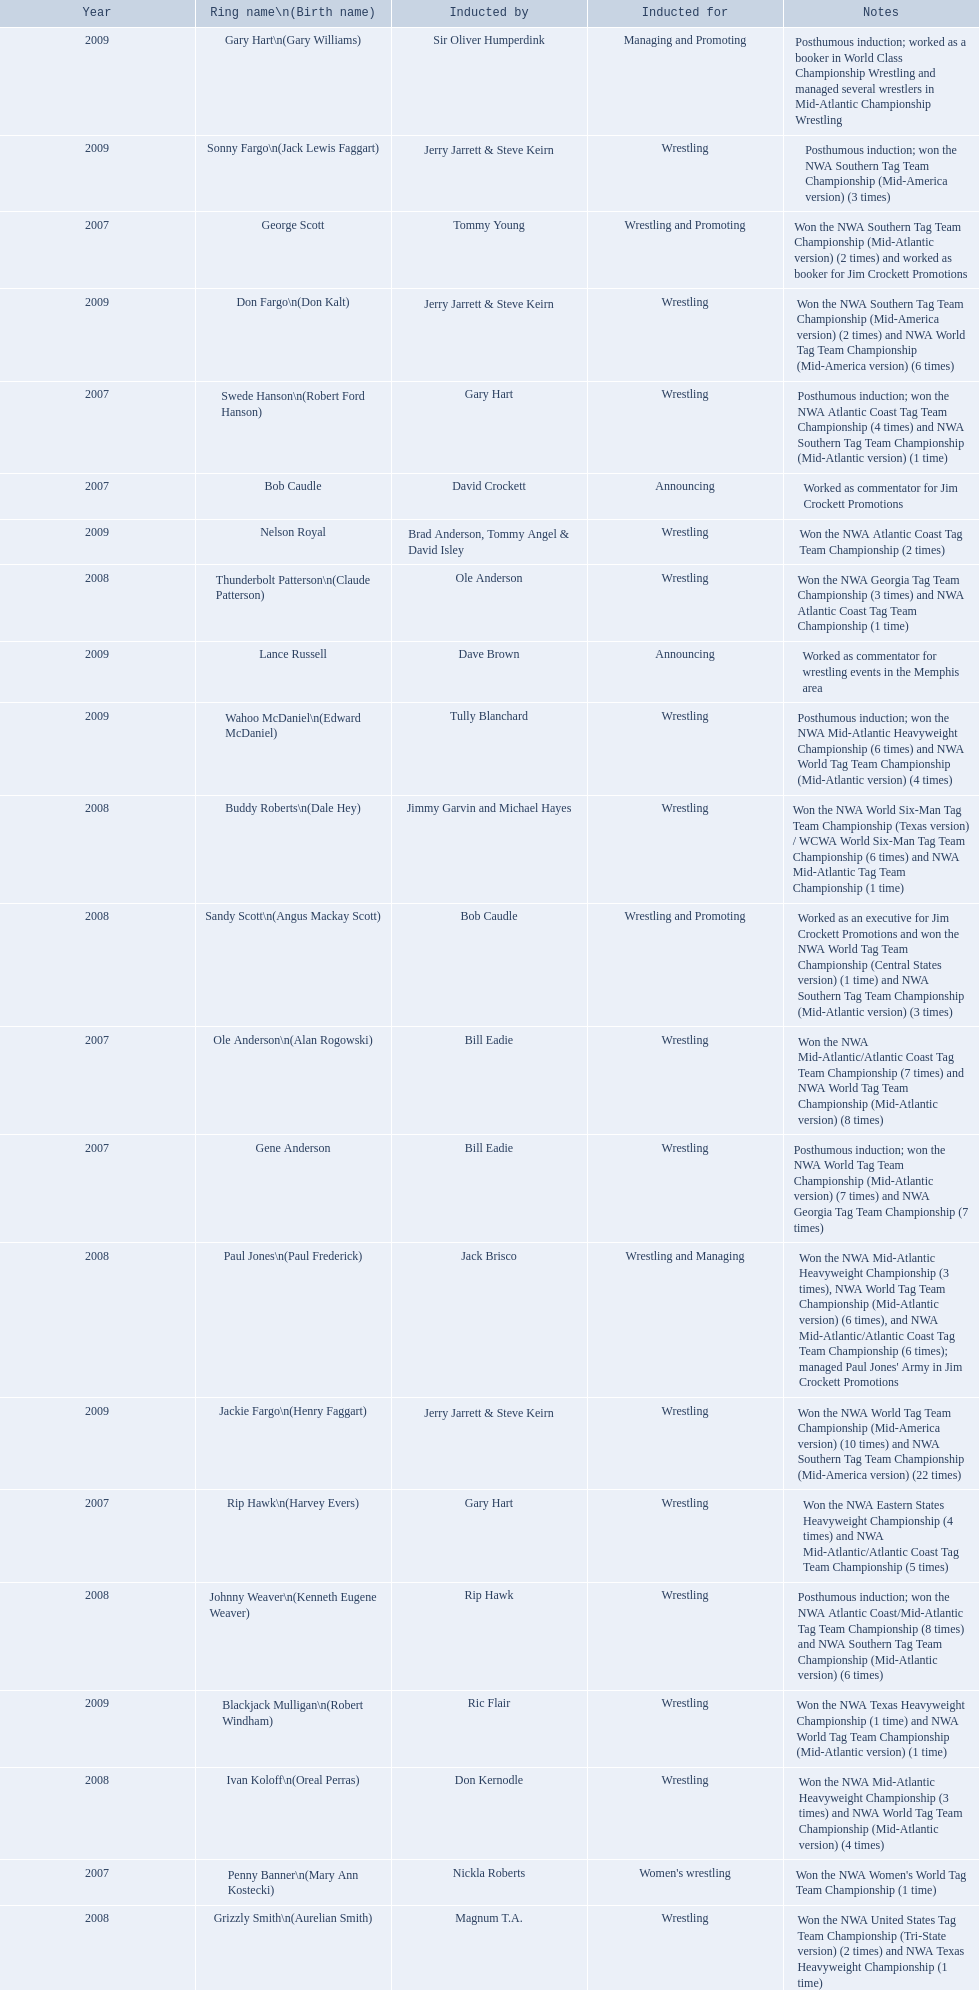Find the word(s) posthumous in the notes column. Posthumous induction; won the NWA World Tag Team Championship (Mid-Atlantic version) (7 times) and NWA Georgia Tag Team Championship (7 times), Posthumous induction; won the NWA Atlantic Coast Tag Team Championship (4 times) and NWA Southern Tag Team Championship (Mid-Atlantic version) (1 time), Posthumous induction; won the NWA Atlantic Coast/Mid-Atlantic Tag Team Championship (8 times) and NWA Southern Tag Team Championship (Mid-Atlantic version) (6 times), Posthumous induction; won the NWA Southern Tag Team Championship (Mid-America version) (3 times), Posthumous induction; worked as a booker in World Class Championship Wrestling and managed several wrestlers in Mid-Atlantic Championship Wrestling, Posthumous induction; won the NWA Mid-Atlantic Heavyweight Championship (6 times) and NWA World Tag Team Championship (Mid-Atlantic version) (4 times). What is the earliest year in the table that wrestlers were inducted? 2007, 2007, 2007, 2007, 2007, 2007, 2007. Find the wrestlers that wrestled underneath their birth name in the earliest year of induction. Gene Anderson, Bob Caudle, George Scott. Of the wrestlers who wrestled underneath their birth name in the earliest year of induction was one of them inducted posthumously? Gene Anderson. 